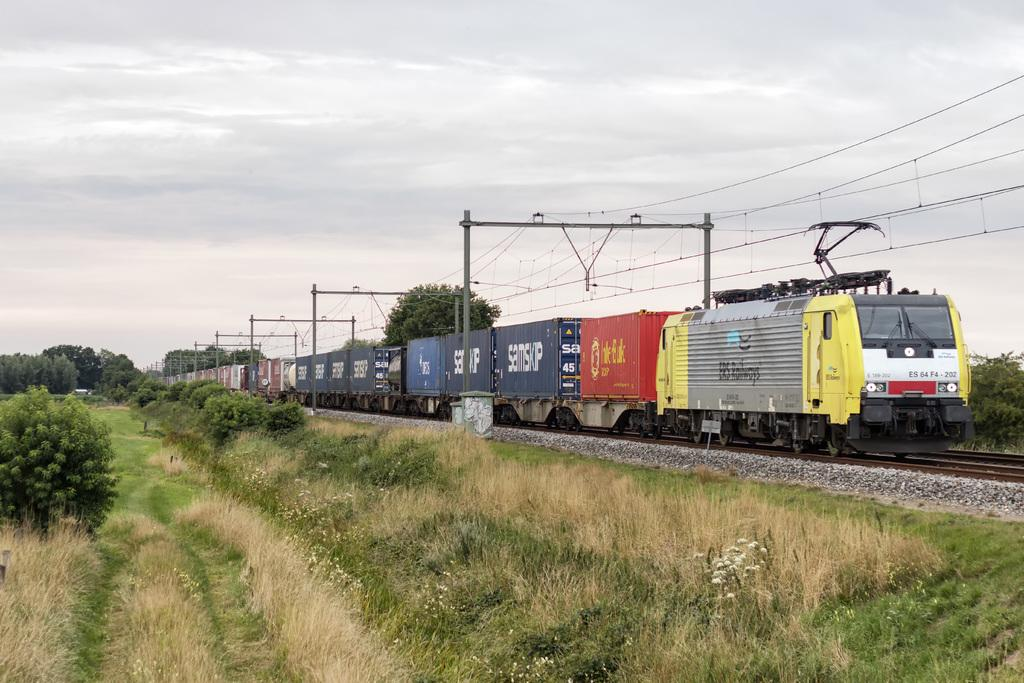Provide a one-sentence caption for the provided image. Train ES 64 F4 - 202 is pulling many cars through a grassy field. 